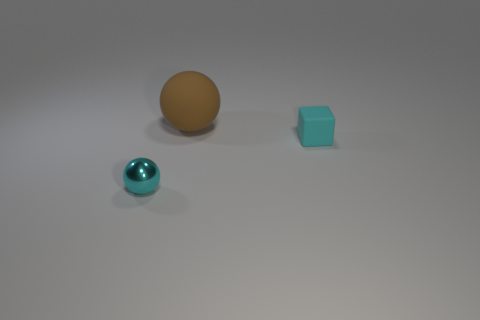What color is the rubber thing in front of the large brown matte object?
Offer a terse response. Cyan. There is a sphere behind the cyan metallic thing; does it have the same size as the cyan object on the right side of the cyan metallic sphere?
Your answer should be very brief. No. How many objects are tiny objects or brown things?
Your answer should be compact. 3. There is a cyan object that is in front of the object that is on the right side of the large brown object; what is it made of?
Provide a short and direct response. Metal. How many other tiny objects are the same shape as the cyan shiny object?
Provide a short and direct response. 0. Is there another rubber sphere that has the same color as the matte ball?
Provide a short and direct response. No. How many objects are things in front of the rubber cube or small cyan metallic things that are in front of the large rubber sphere?
Your answer should be compact. 1. Are there any brown spheres behind the ball behind the cyan block?
Provide a succinct answer. No. There is a cyan rubber object that is the same size as the metallic object; what shape is it?
Your response must be concise. Cube. What number of objects are either spheres left of the brown rubber thing or small cyan objects?
Provide a short and direct response. 2. 